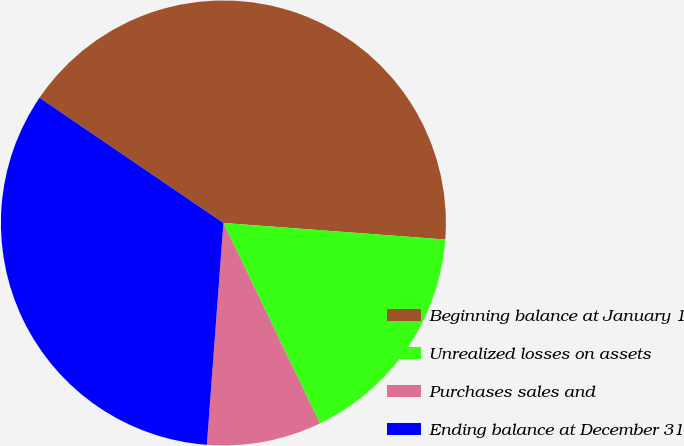<chart> <loc_0><loc_0><loc_500><loc_500><pie_chart><fcel>Beginning balance at January 1<fcel>Unrealized losses on assets<fcel>Purchases sales and<fcel>Ending balance at December 31<nl><fcel>41.67%<fcel>16.67%<fcel>8.33%<fcel>33.33%<nl></chart> 